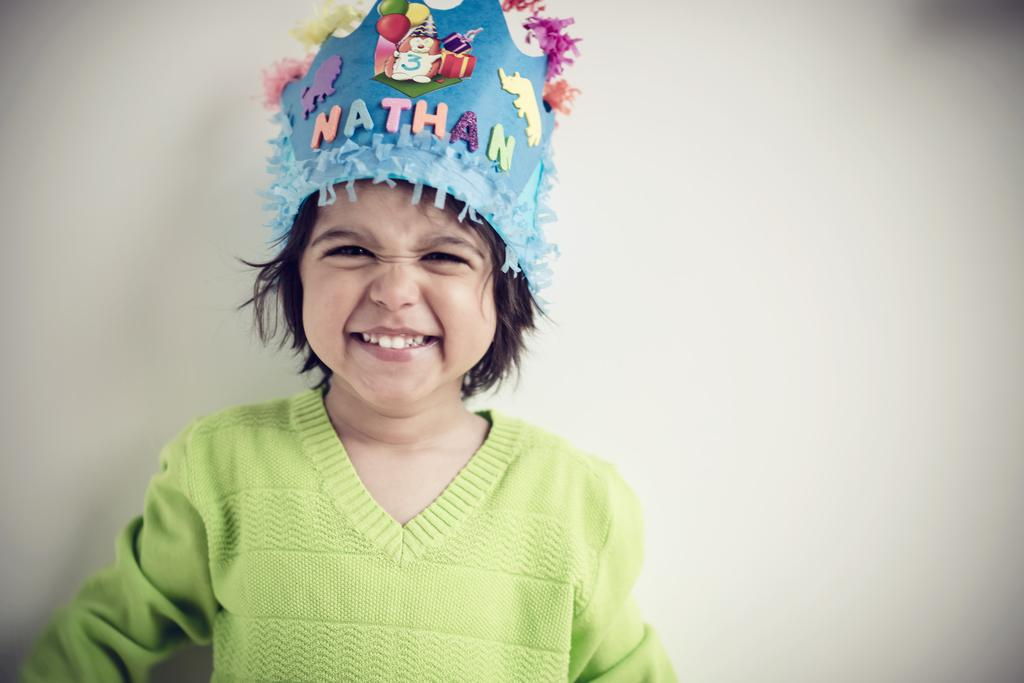What is the main subject of the image? The main subject of the image is a girl. What is the girl wearing on her head? The girl is wearing a cap. Is there any text or design on the cap? Yes, there is text on the cap. What can be seen in the background of the image? There is a wall in the background of the image. What type of authority does the girl have in the bedroom in the image? There is no bedroom present in the image, and the girl's authority is not mentioned or depicted. Is it raining in the image? There is no indication of rain in the image; the girl is standing in front of a wall. 